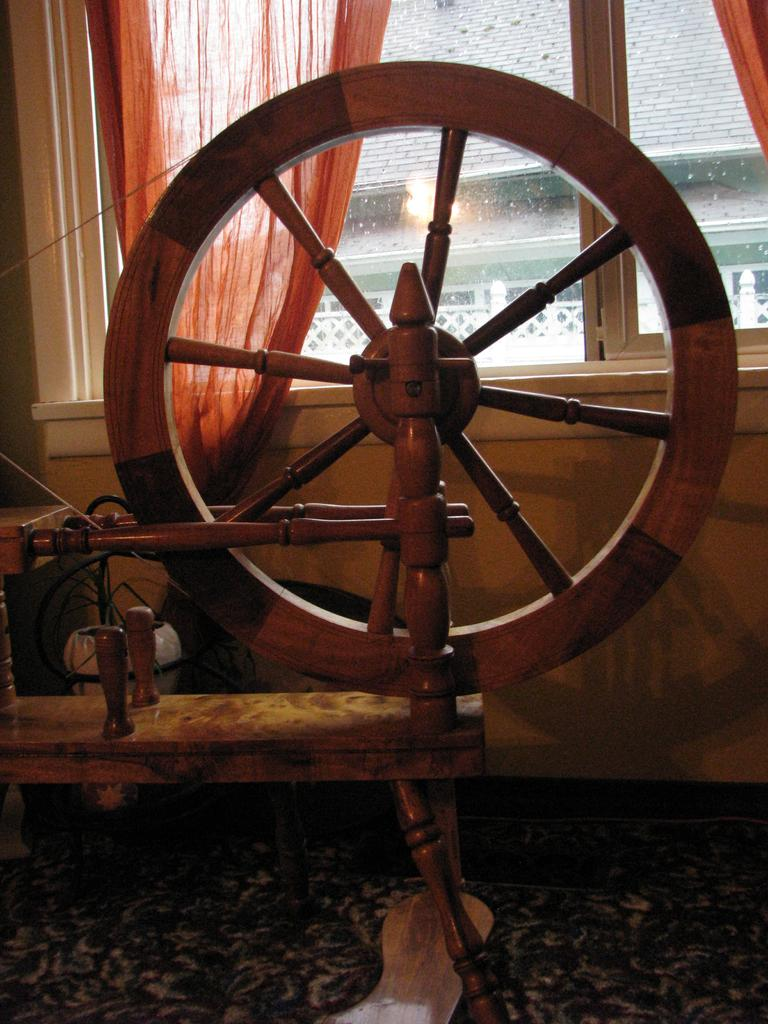What type of object is on the floor in the image? There is a wooden object on the floor. What can be seen on the wall in the image? There is a wall with windows in the image. What is associated with the windows on the wall? There are curtains associated with the windows. What is visible through the windows in the image? Buildings with lights are visible through the windows. Where is the pig located in the image? There is no pig present in the image. What is the name of the son in the image? There is no son present in the image. 